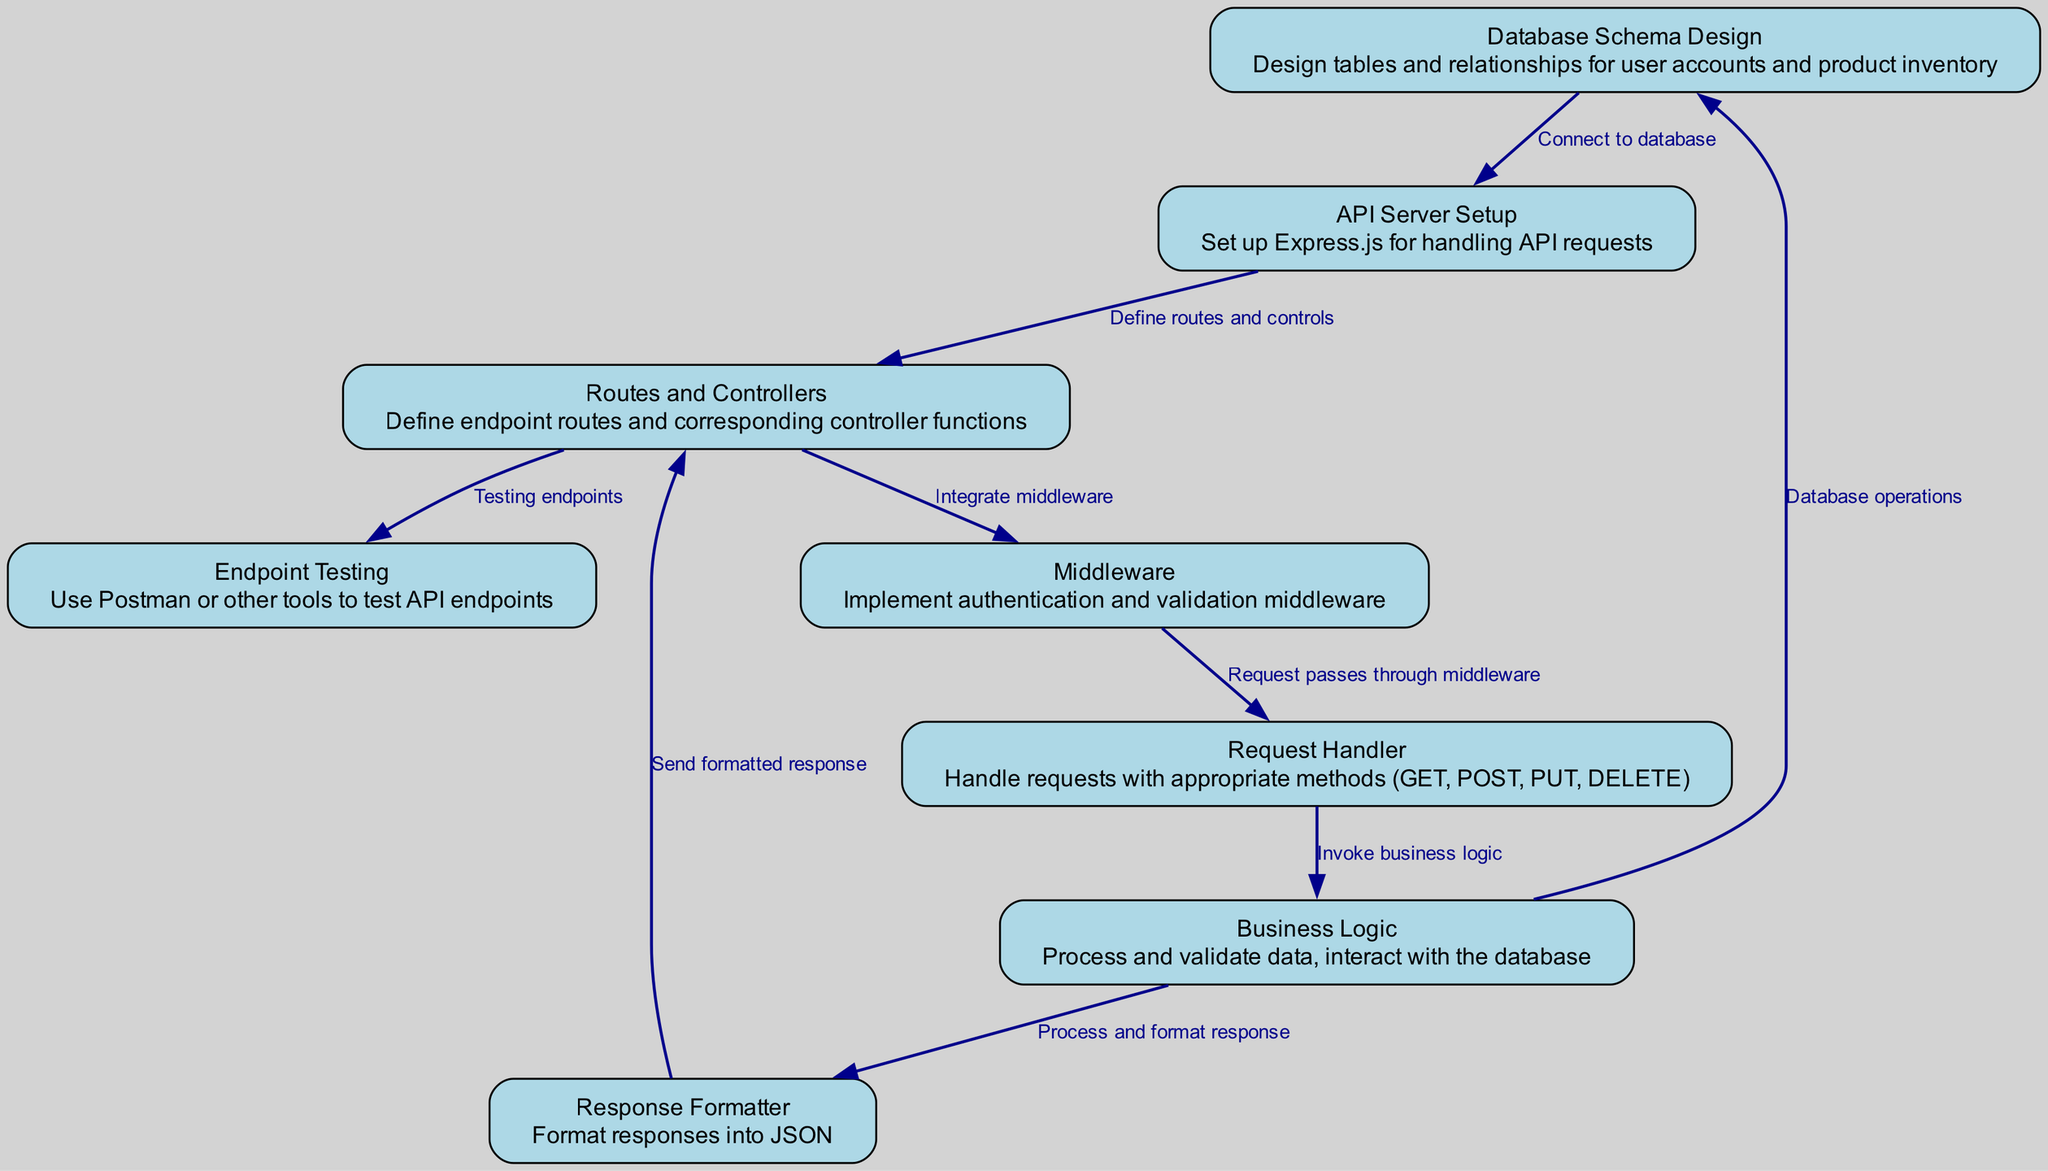What is the first step in setting up a RESTful API according to the diagram? The diagram indicates that the first step is "Database Schema Design," where tables and relationships for user accounts and product inventory are designed.
Answer: Database Schema Design How many nodes are there in the diagram? By counting the nodes listed in the diagram, there are eight nodes total, representing the different components in the setup process.
Answer: Eight Which component directly follows Middleware in the request handling process? The diagram shows that the "Request Handler" follows "Middleware," indicating the flow of requests after they pass through the middleware layer.
Answer: Request Handler What is the relationship between Business Logic and Database Schema in the diagram? The diagram specifies that "Business Logic" interacts with "Database Schema" for database operations, establishing a direct relationship between the two components.
Answer: Database operations What is the final component that receives a response in the request handling flow? According to the flow of the diagram, the "Routes Controller" is the final component to receive the formatted response from the "Response Formatter."
Answer: Routes Controller Which tools are suggested for testing API endpoints? The diagram suggests the use of "Postman or other tools" for testing API endpoints, reflecting common practices for testing APIs.
Answer: Postman or other tools How does the API Server connect to the database according to the diagram? The diagram indicates that the connection is established from "Database Schema Design" to "API Server," emphasizing the link between database design and server setup.
Answer: Connect to database What happens after the Request Handler invokes Business Logic? After the "Request Handler" invokes "Business Logic," the next step is that "Business Logic" then proceeds to perform database operations with "Database Schema."
Answer: Database operations How many edges are connecting the nodes in the diagram? Counting the edges shown, there are eight connections that represent the relationships and flow of data between the nodes in the diagram.
Answer: Eight 